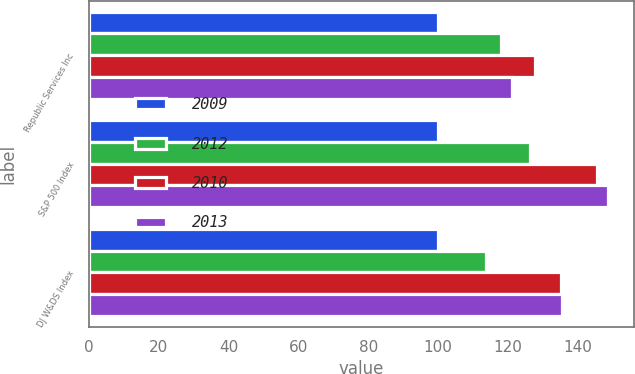Convert chart to OTSL. <chart><loc_0><loc_0><loc_500><loc_500><stacked_bar_chart><ecel><fcel>Republic Services Inc<fcel>S&P 500 Index<fcel>DJ W&DS Index<nl><fcel>2009<fcel>100<fcel>100<fcel>100<nl><fcel>2012<fcel>118<fcel>126.46<fcel>113.83<nl><fcel>2010<fcel>127.75<fcel>145.51<fcel>135.21<nl><fcel>2013<fcel>121.32<fcel>148.59<fcel>135.45<nl></chart> 